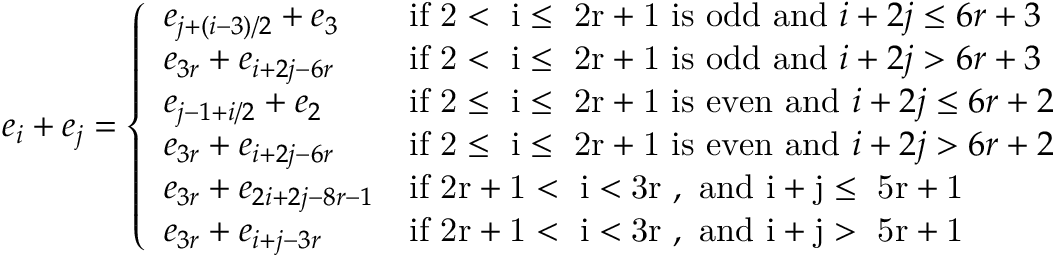<formula> <loc_0><loc_0><loc_500><loc_500>e _ { i } + e _ { j } = \left \{ \begin{array} { l l } { e _ { j + ( i - 3 ) / 2 } + e _ { 3 } } & { i f 2 < i \leq 2 r + 1 i s o d d a n d i + 2 j \leq 6 r + 3 } \\ { e _ { 3 r } + e _ { i + 2 j - 6 r } } & { i f 2 < i \leq 2 r + 1 i s o d d a n d i + 2 j > 6 r + 3 } \\ { e _ { j - 1 + i / 2 } + e _ { 2 } } & { i f 2 \leq i \leq 2 r + 1 i s e v e n a n d i + 2 j \leq 6 r + 2 } \\ { e _ { 3 r } + e _ { i + 2 j - 6 r } } & { i f 2 \leq i \leq 2 r + 1 i s e v e n a n d i + 2 j > 6 r + 2 } \\ { e _ { 3 r } + e _ { 2 i + 2 j - 8 r - 1 } } & { i f 2 r + 1 < i < 3 r , a n d i + j \leq 5 r + 1 } \\ { e _ { 3 r } + e _ { i + j - 3 r } } & { i f 2 r + 1 < i < 3 r , a n d i + j > 5 r + 1 } \end{array}</formula> 